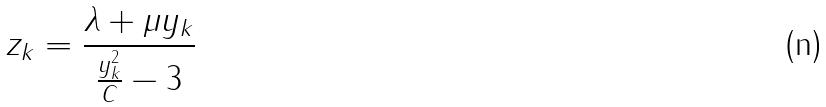<formula> <loc_0><loc_0><loc_500><loc_500>z _ { k } = \frac { \lambda + \mu y _ { k } } { \frac { y _ { k } ^ { 2 } } { C } - 3 }</formula> 